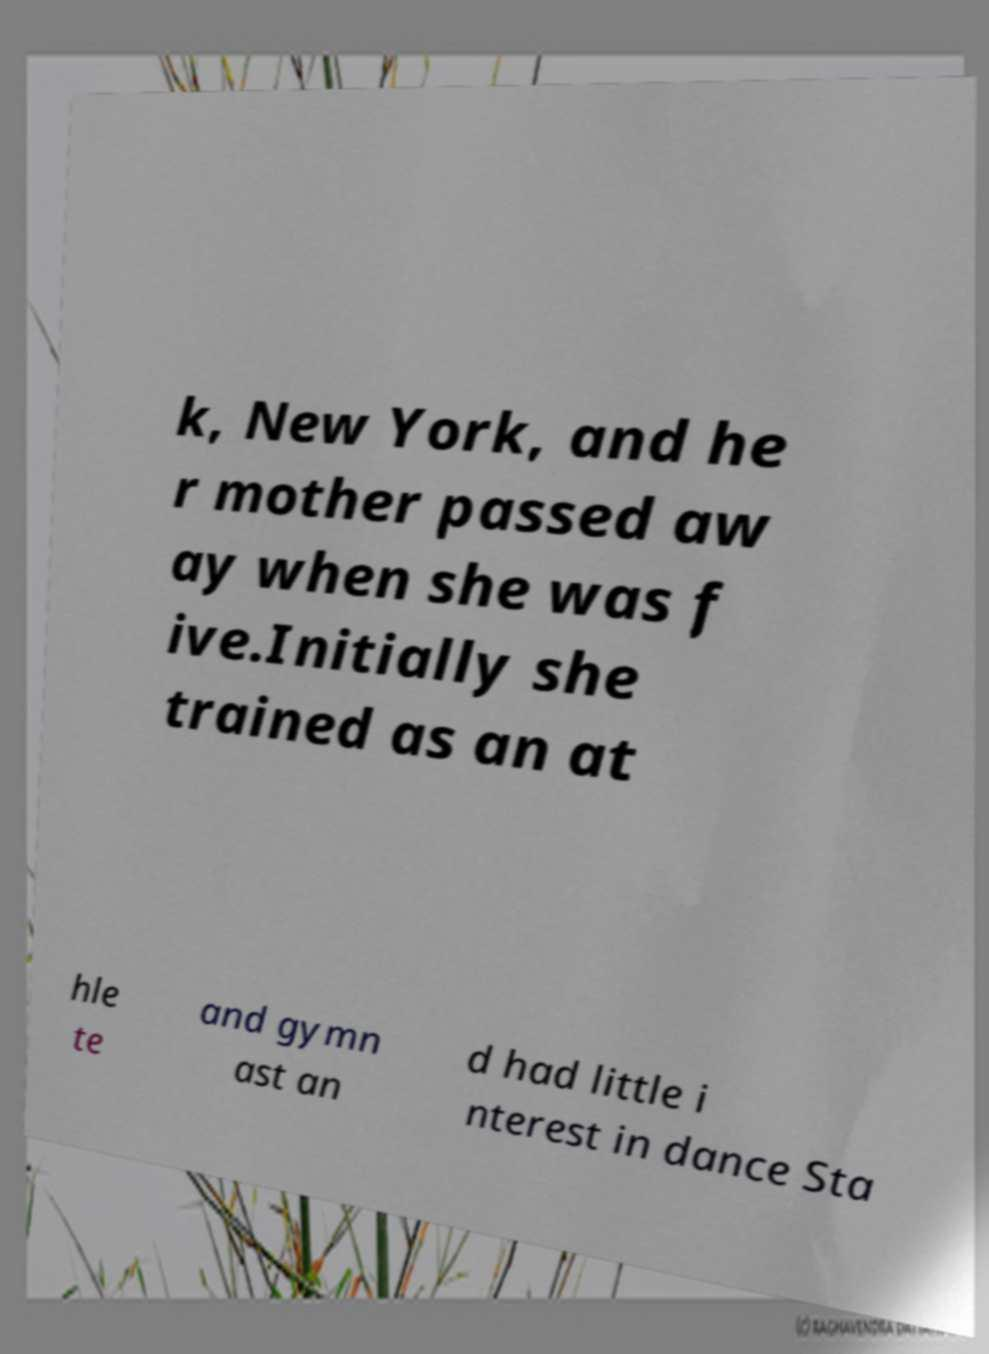I need the written content from this picture converted into text. Can you do that? k, New York, and he r mother passed aw ay when she was f ive.Initially she trained as an at hle te and gymn ast an d had little i nterest in dance Sta 